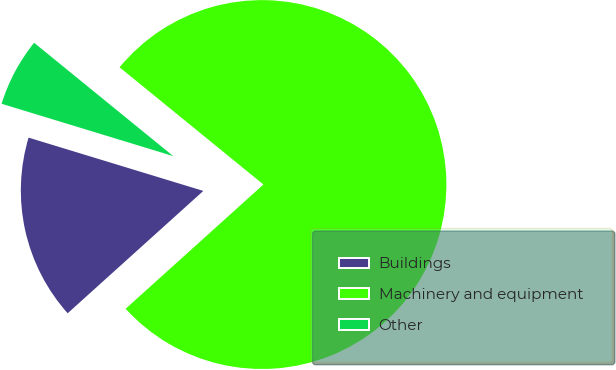<chart> <loc_0><loc_0><loc_500><loc_500><pie_chart><fcel>Buildings<fcel>Machinery and equipment<fcel>Other<nl><fcel>16.39%<fcel>77.44%<fcel>6.17%<nl></chart> 